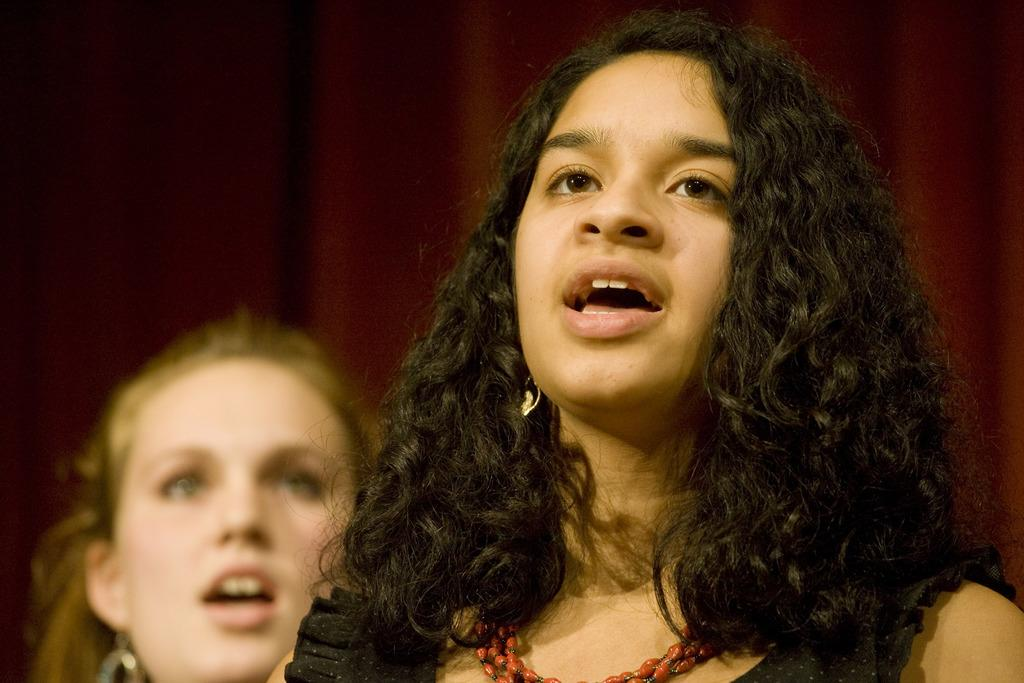How many people are in the image? There are two persons in the image. What is the girl on the right wearing? The girl on the right is wearing a black dress. What is the girl on the right doing? The girl on the right appears to be singing. What color is the curtain in the background of the image? There is a maroon-colored curtain in the background of the image. What type of credit card is the girl on the right holding in the image? There is no credit card visible in the image; the girl on the right is singing and wearing a black dress. What kind of apparatus is being used by the girl on the right to sing? There is no apparatus visible in the image; the girl on the right appears to be singing without any visible equipment. 